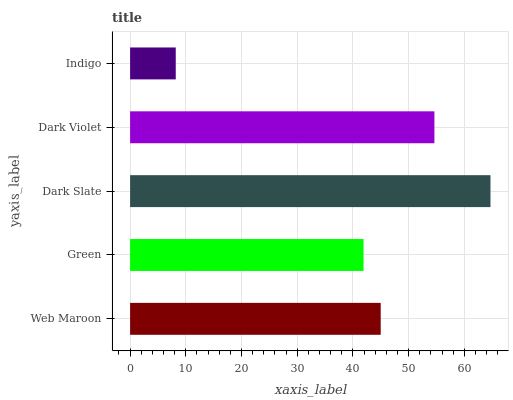Is Indigo the minimum?
Answer yes or no. Yes. Is Dark Slate the maximum?
Answer yes or no. Yes. Is Green the minimum?
Answer yes or no. No. Is Green the maximum?
Answer yes or no. No. Is Web Maroon greater than Green?
Answer yes or no. Yes. Is Green less than Web Maroon?
Answer yes or no. Yes. Is Green greater than Web Maroon?
Answer yes or no. No. Is Web Maroon less than Green?
Answer yes or no. No. Is Web Maroon the high median?
Answer yes or no. Yes. Is Web Maroon the low median?
Answer yes or no. Yes. Is Dark Slate the high median?
Answer yes or no. No. Is Green the low median?
Answer yes or no. No. 